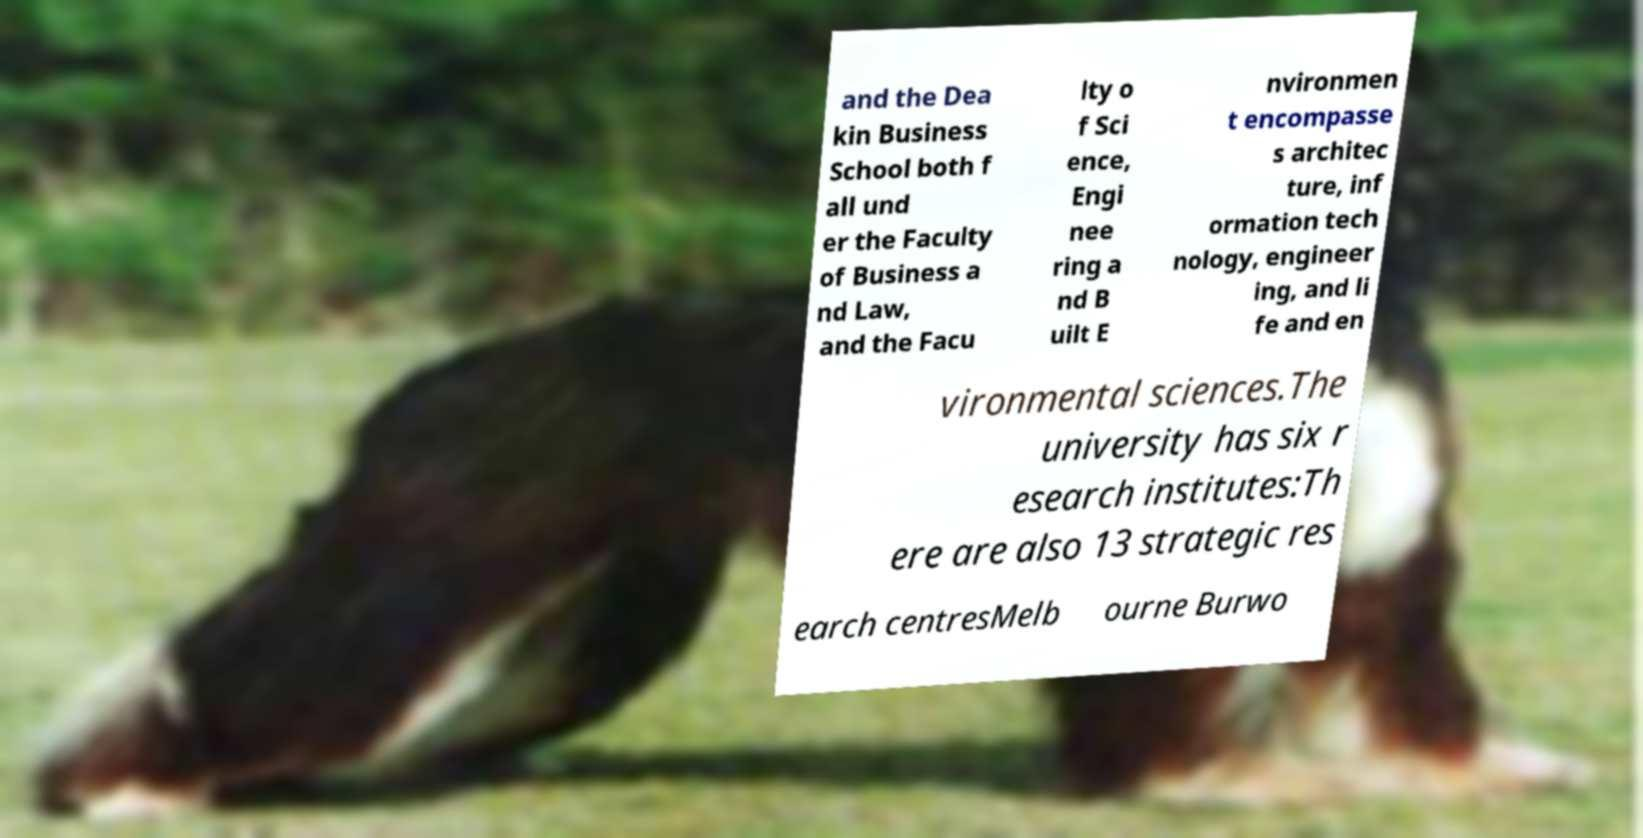What messages or text are displayed in this image? I need them in a readable, typed format. and the Dea kin Business School both f all und er the Faculty of Business a nd Law, and the Facu lty o f Sci ence, Engi nee ring a nd B uilt E nvironmen t encompasse s architec ture, inf ormation tech nology, engineer ing, and li fe and en vironmental sciences.The university has six r esearch institutes:Th ere are also 13 strategic res earch centresMelb ourne Burwo 